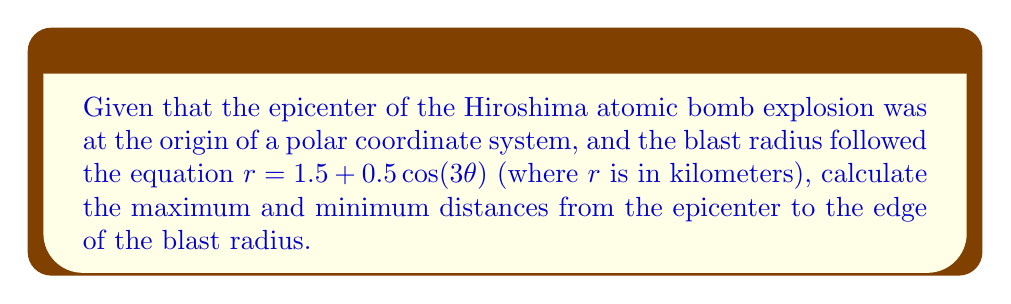What is the answer to this math problem? To solve this problem, we need to analyze the given polar equation:

$$r = 1.5 + 0.5\cos(3\theta)$$

1) The maximum distance occurs when $\cos(3\theta)$ is at its maximum value of 1, and the minimum distance occurs when $\cos(3\theta)$ is at its minimum value of -1.

2) For the maximum distance:
   $$r_{max} = 1.5 + 0.5(1) = 1.5 + 0.5 = 2\text{ km}$$

3) For the minimum distance:
   $$r_{min} = 1.5 + 0.5(-1) = 1.5 - 0.5 = 1\text{ km}$$

4) We can visualize this blast radius using the following Asymptote diagram:

[asy]
import graph;
size(200);
real r(real t) {return 1.5+0.5*cos(3t);}
draw(polargraph(r,0,2pi),red);
draw(circle((0,0),1),blue+dashed);
draw(circle((0,0),2),blue+dashed);
label("1 km", (1,0), E);
label("2 km", (2,0), E);
label("Epicenter", (0,0), SW);
[/asy]

The red curve represents the blast radius, while the blue dashed circles show the minimum and maximum distances.
Answer: The maximum distance from the epicenter to the edge of the blast radius is 2 km, and the minimum distance is 1 km. 